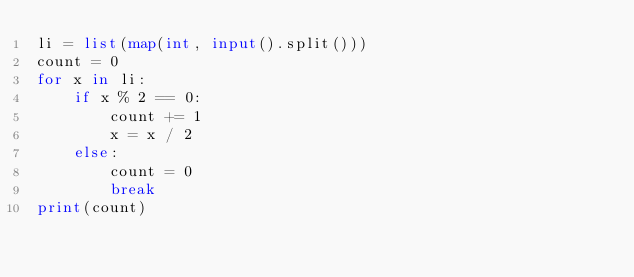<code> <loc_0><loc_0><loc_500><loc_500><_Python_>li = list(map(int, input().split()))
count = 0
for x in li:
    if x % 2 == 0:
        count += 1
        x = x / 2
    else:
        count = 0
        break
print(count)</code> 